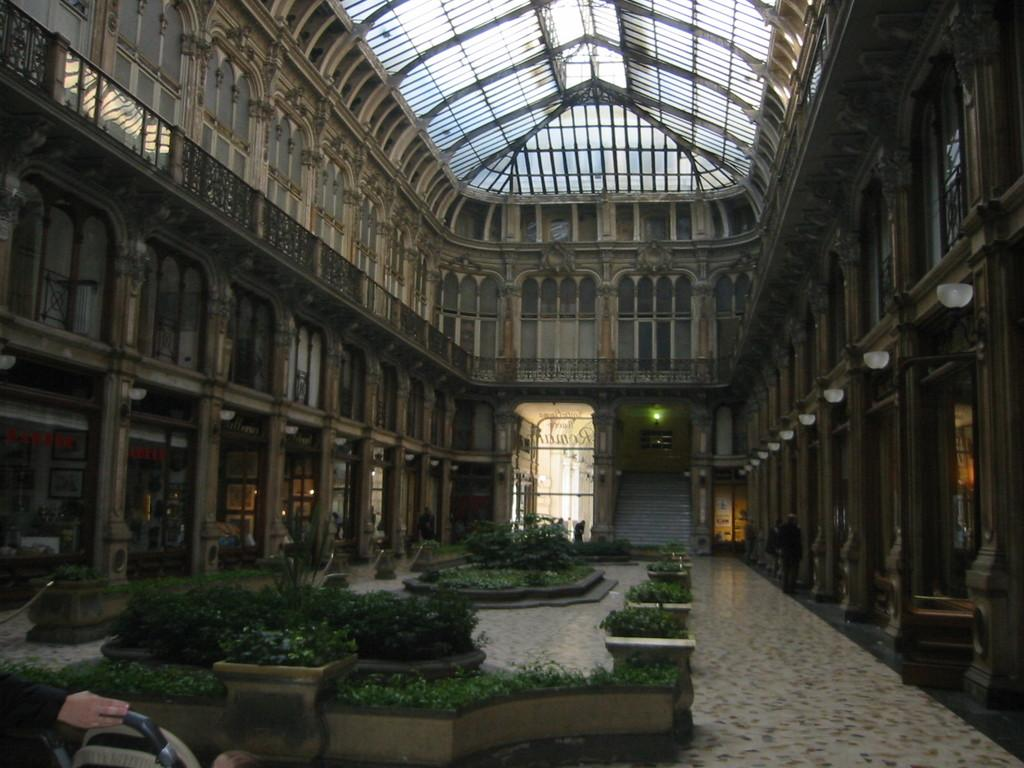What type of structure is present in the image? There is a building in the image. What type of lighting is visible in the image? There are electric lights in the image. What type of vertical structures are present in the image? There are poles in the image. What type of signage is present in the image? There are name boards in the image. What type of vegetation is present in the image? There are houseplants in the image. What type of note is attached to the sugar in the image? There is no sugar or note present in the image. What type of seed is visible growing on the seed in the image? There is no seed or seedling present in the image. 